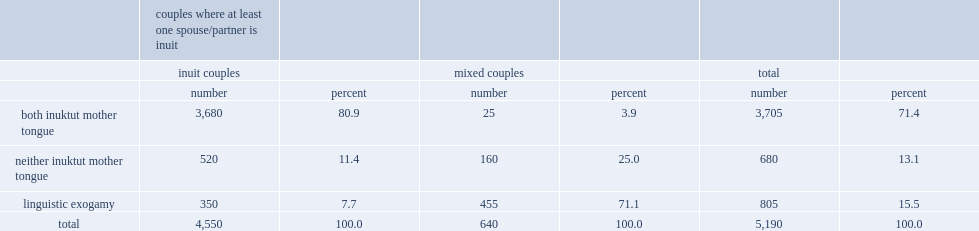In nunavut, what was the percent of couples with at least one inuit spouse or partner, inuktut is the mother tongue of both partners? 71.4. What was the percent of couples where both members are inuit are linguistically exogamous? 7.7. What was the percent of inuit couples, inuktut is not the mother tongue of either partner? 11.4. What was the percent of mixed couples (i.e., couples made up of one inuit and one non-inuit) are linguistically exogamous? 71.1. Write the full table. {'header': ['', 'couples where at least one spouse/partner is inuit', '', '', '', '', ''], 'rows': [['', 'inuit couples', '', 'mixed couples', '', 'total', ''], ['', 'number', 'percent', 'number', 'percent', 'number', 'percent'], ['both inuktut mother tongue', '3,680', '80.9', '25', '3.9', '3,705', '71.4'], ['neither inuktut mother tongue', '520', '11.4', '160', '25.0', '680', '13.1'], ['linguistic exogamy', '350', '7.7', '455', '71.1', '805', '15.5'], ['total', '4,550', '100.0', '640', '100.0', '5,190', '100.0']]} 